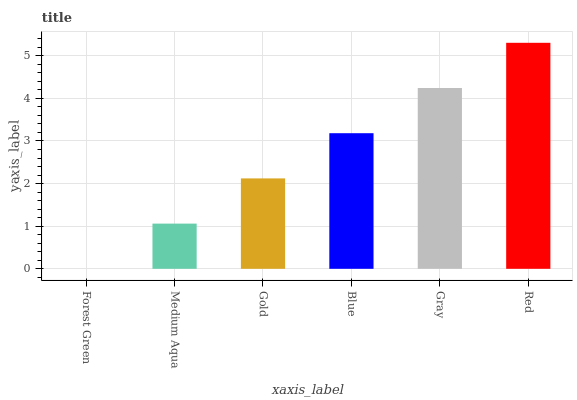Is Forest Green the minimum?
Answer yes or no. Yes. Is Red the maximum?
Answer yes or no. Yes. Is Medium Aqua the minimum?
Answer yes or no. No. Is Medium Aqua the maximum?
Answer yes or no. No. Is Medium Aqua greater than Forest Green?
Answer yes or no. Yes. Is Forest Green less than Medium Aqua?
Answer yes or no. Yes. Is Forest Green greater than Medium Aqua?
Answer yes or no. No. Is Medium Aqua less than Forest Green?
Answer yes or no. No. Is Blue the high median?
Answer yes or no. Yes. Is Gold the low median?
Answer yes or no. Yes. Is Gold the high median?
Answer yes or no. No. Is Red the low median?
Answer yes or no. No. 